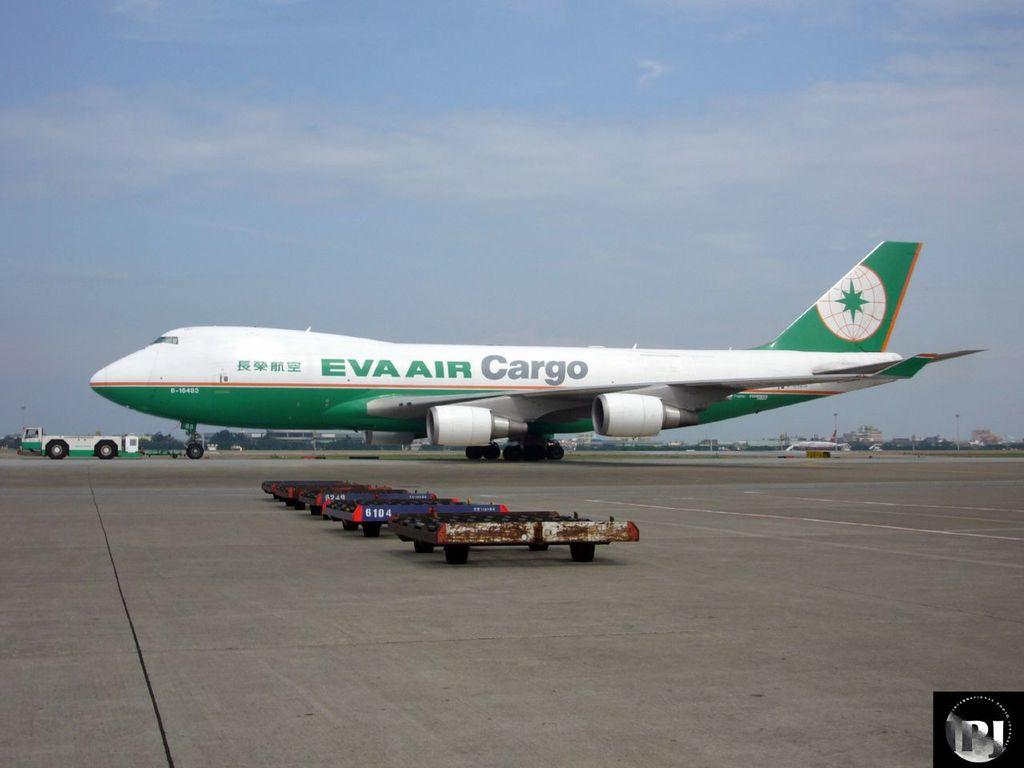<image>
Give a short and clear explanation of the subsequent image. A large plane that is owned by Eva Air Cargo. 